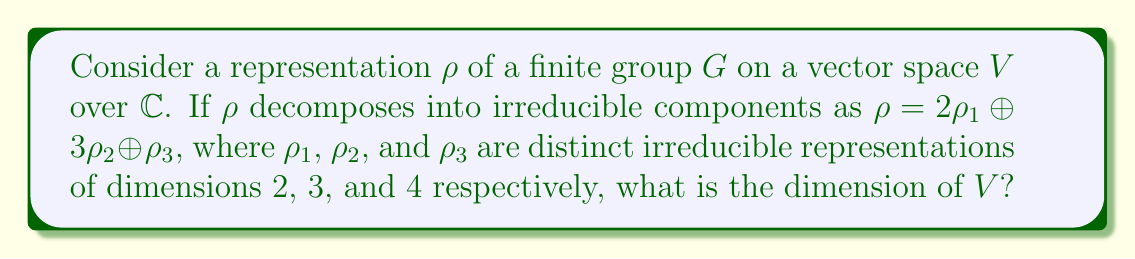What is the answer to this math problem? To find the dimension of $V$, we need to follow these steps:

1) In the decomposition $\rho = 2\rho_1 \oplus 3\rho_2 \oplus \rho_3$, the coefficients represent the multiplicity of each irreducible representation.

2) We need to calculate the dimension of each component:

   a) For $\rho_1$: It appears twice and has dimension 2
      Contribution: $2 \times 2 = 4$

   b) For $\rho_2$: It appears three times and has dimension 3
      Contribution: $3 \times 3 = 9$

   c) For $\rho_3$: It appears once and has dimension 4
      Contribution: $1 \times 4 = 4$

3) The total dimension of $V$ is the sum of these contributions:

   $\dim(V) = 4 + 9 + 4 = 17$

This calculation is analogous to organizing genealogical documents, where different types of records (like birth, marriage, and death certificates) might occupy different amounts of space in an archive.
Answer: 17 